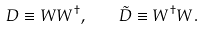Convert formula to latex. <formula><loc_0><loc_0><loc_500><loc_500>D \equiv W W ^ { \dagger } , \quad \tilde { D } \equiv W ^ { \dagger } W .</formula> 